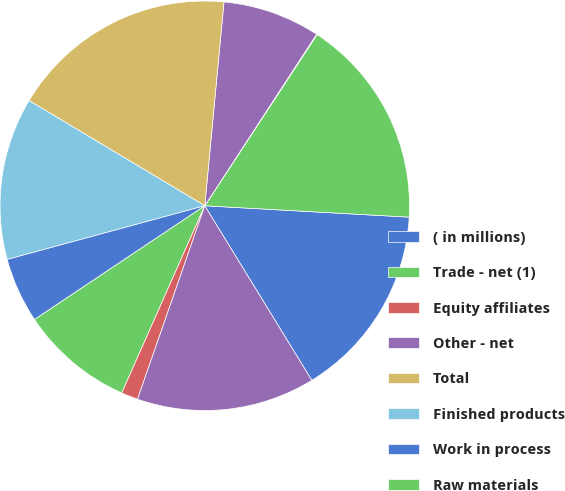Convert chart. <chart><loc_0><loc_0><loc_500><loc_500><pie_chart><fcel>( in millions)<fcel>Trade - net (1)<fcel>Equity affiliates<fcel>Other - net<fcel>Total<fcel>Finished products<fcel>Work in process<fcel>Raw materials<fcel>Supplies<fcel>Trade<nl><fcel>15.36%<fcel>16.64%<fcel>0.05%<fcel>7.7%<fcel>17.91%<fcel>12.81%<fcel>5.15%<fcel>8.98%<fcel>1.32%<fcel>14.08%<nl></chart> 